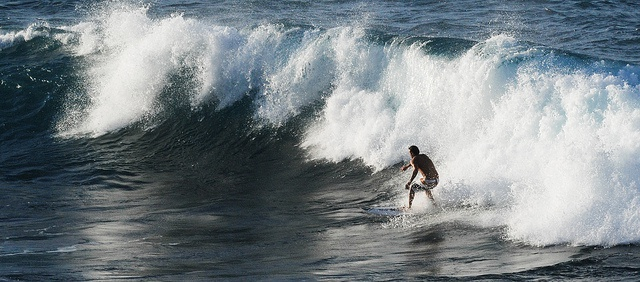Describe the objects in this image and their specific colors. I can see people in blue, black, gray, darkgray, and lightgray tones, surfboard in blue, darkgray, lightgray, and gray tones, and surfboard in blue, darkgray, and gray tones in this image. 